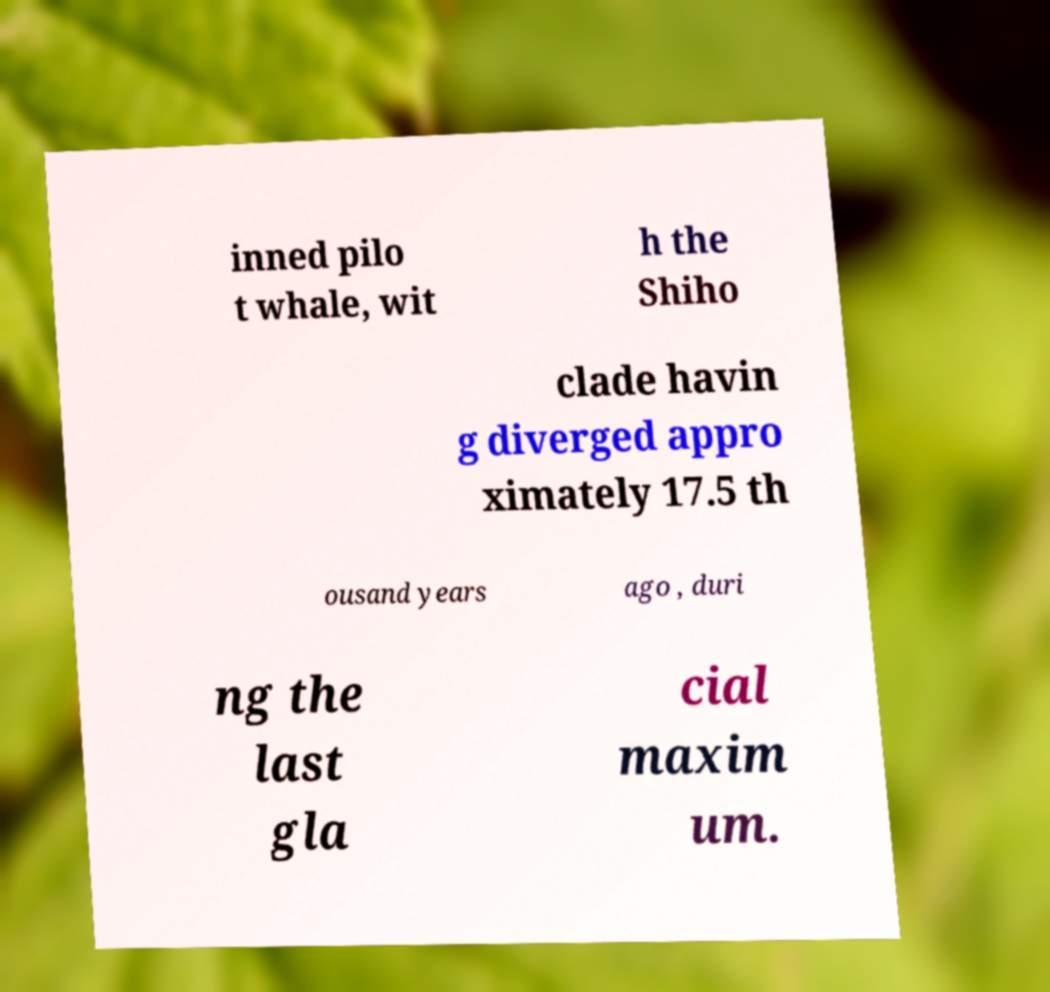There's text embedded in this image that I need extracted. Can you transcribe it verbatim? inned pilo t whale, wit h the Shiho clade havin g diverged appro ximately 17.5 th ousand years ago , duri ng the last gla cial maxim um. 